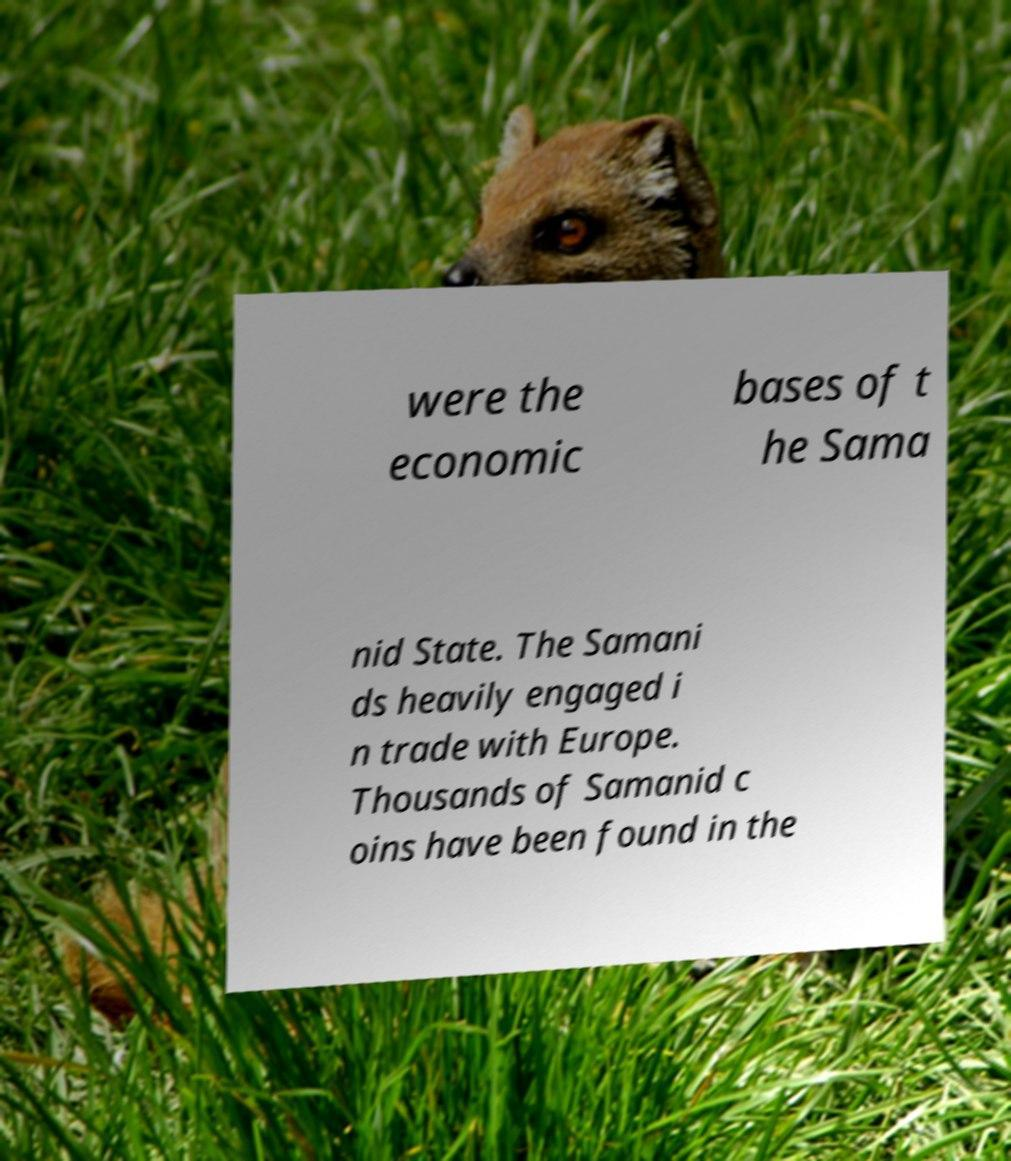For documentation purposes, I need the text within this image transcribed. Could you provide that? were the economic bases of t he Sama nid State. The Samani ds heavily engaged i n trade with Europe. Thousands of Samanid c oins have been found in the 